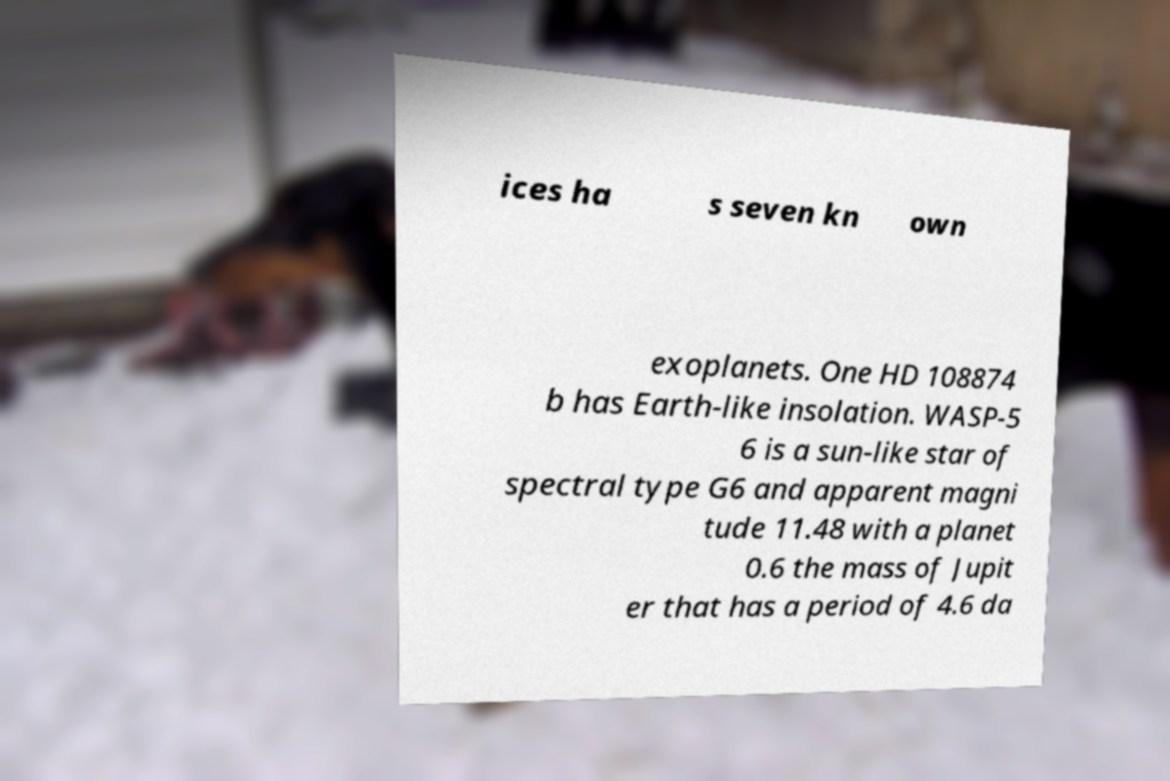Please read and relay the text visible in this image. What does it say? ices ha s seven kn own exoplanets. One HD 108874 b has Earth-like insolation. WASP-5 6 is a sun-like star of spectral type G6 and apparent magni tude 11.48 with a planet 0.6 the mass of Jupit er that has a period of 4.6 da 